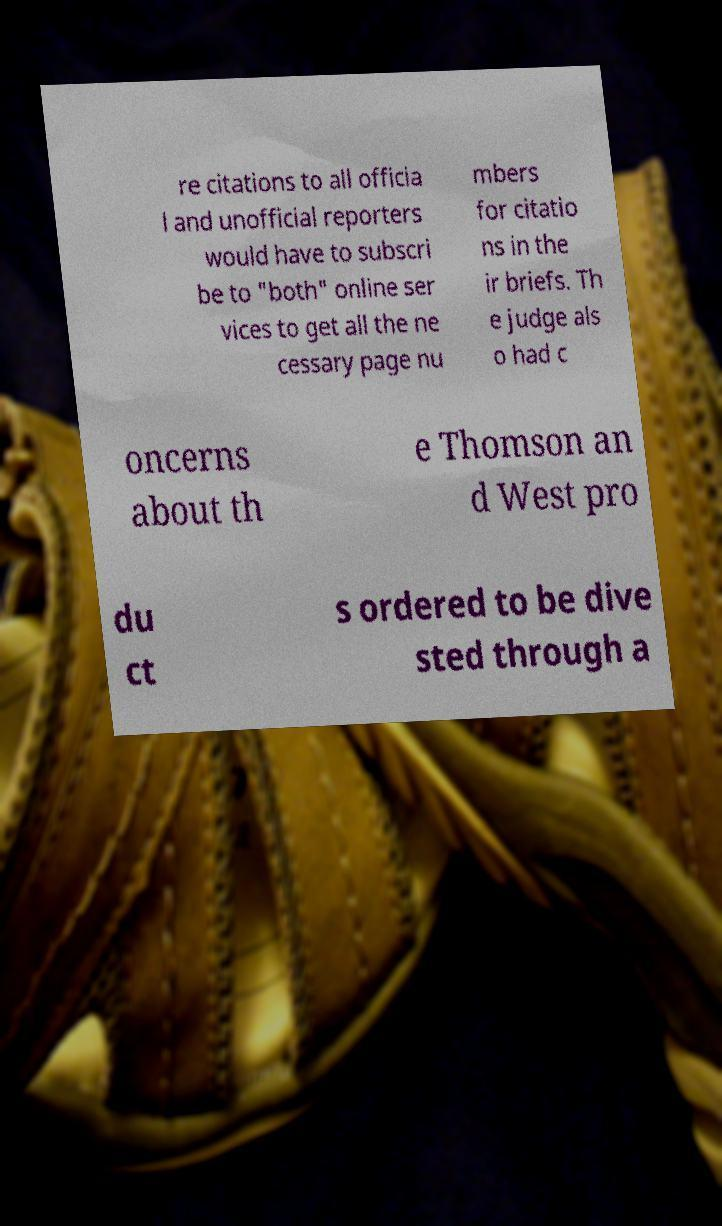Can you read and provide the text displayed in the image?This photo seems to have some interesting text. Can you extract and type it out for me? re citations to all officia l and unofficial reporters would have to subscri be to "both" online ser vices to get all the ne cessary page nu mbers for citatio ns in the ir briefs. Th e judge als o had c oncerns about th e Thomson an d West pro du ct s ordered to be dive sted through a 